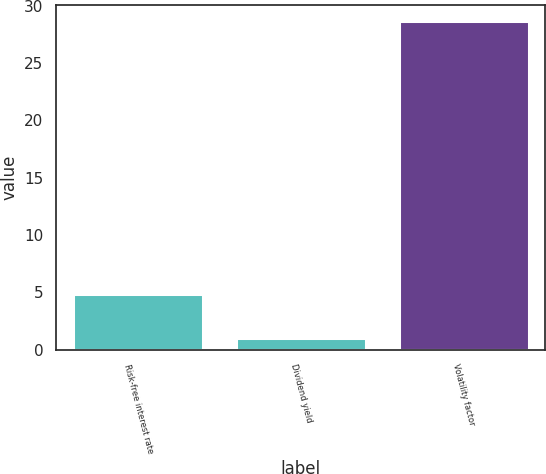<chart> <loc_0><loc_0><loc_500><loc_500><bar_chart><fcel>Risk-free interest rate<fcel>Dividend yield<fcel>Volatility factor<nl><fcel>4.82<fcel>0.97<fcel>28.64<nl></chart> 